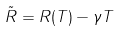Convert formula to latex. <formula><loc_0><loc_0><loc_500><loc_500>\tilde { R } = R ( T ) - \gamma T</formula> 